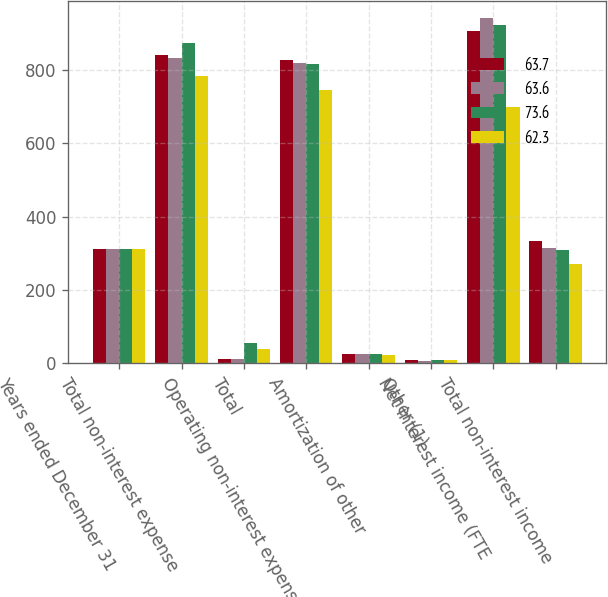Convert chart to OTSL. <chart><loc_0><loc_0><loc_500><loc_500><stacked_bar_chart><ecel><fcel>Years ended December 31<fcel>Total non-interest expense<fcel>Total<fcel>Operating non-interest expense<fcel>Amortization of other<fcel>Other (1)<fcel>Net interest income (FTE<fcel>Total non-interest income<nl><fcel>63.7<fcel>310.7<fcel>839<fcel>12.7<fcel>826.3<fcel>26.2<fcel>10.3<fcel>905.8<fcel>333.2<nl><fcel>63.6<fcel>310.7<fcel>830.6<fcel>12.7<fcel>817.9<fcel>26.8<fcel>7.8<fcel>940.4<fcel>313.8<nl><fcel>73.6<fcel>310.7<fcel>871.9<fcel>56.8<fcel>815.1<fcel>25.8<fcel>10.3<fcel>921.2<fcel>307.6<nl><fcel>62.3<fcel>310.7<fcel>782<fcel>38.6<fcel>743.4<fcel>21.7<fcel>9.4<fcel>697.3<fcel>270<nl></chart> 